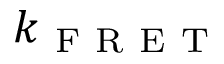Convert formula to latex. <formula><loc_0><loc_0><loc_500><loc_500>k _ { F R E T }</formula> 